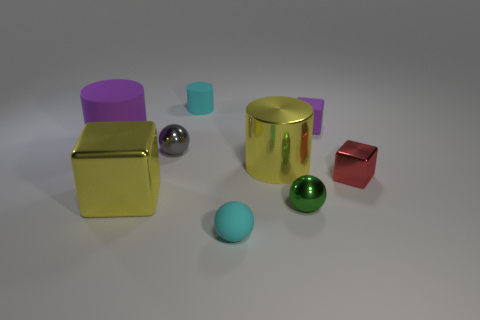Subtract all spheres. How many objects are left? 6 Subtract 3 spheres. How many spheres are left? 0 Subtract all red spheres. Subtract all blue cylinders. How many spheres are left? 3 Subtract all yellow cylinders. How many green balls are left? 1 Subtract all large cyan matte cylinders. Subtract all big purple things. How many objects are left? 8 Add 5 big matte cylinders. How many big matte cylinders are left? 6 Add 3 yellow cylinders. How many yellow cylinders exist? 4 Add 1 tiny green spheres. How many objects exist? 10 Subtract all green metallic balls. How many balls are left? 2 Subtract 1 gray spheres. How many objects are left? 8 